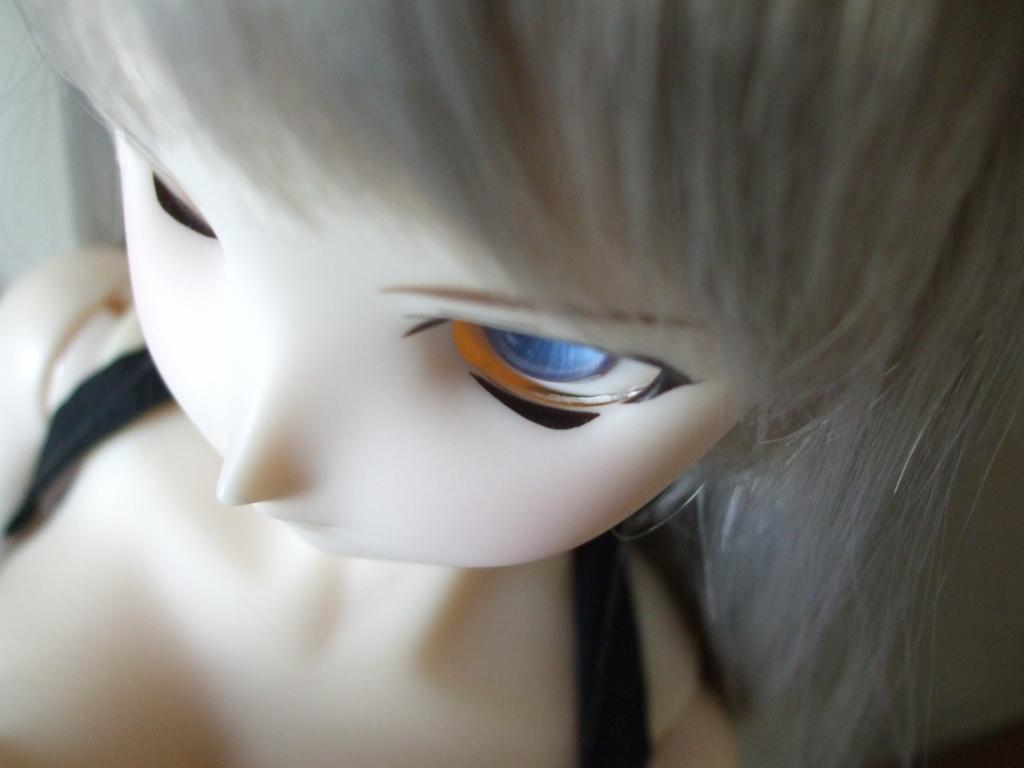What is the main subject in the image? There is a doll in the image. Can you describe the objects on both sides of the image? There are black color objects on both sides of the image. What type of corn can be seen growing in the image? There is no corn present in the image. What achievements has the cork made in the image? There is no cork or achiever present in the image. 